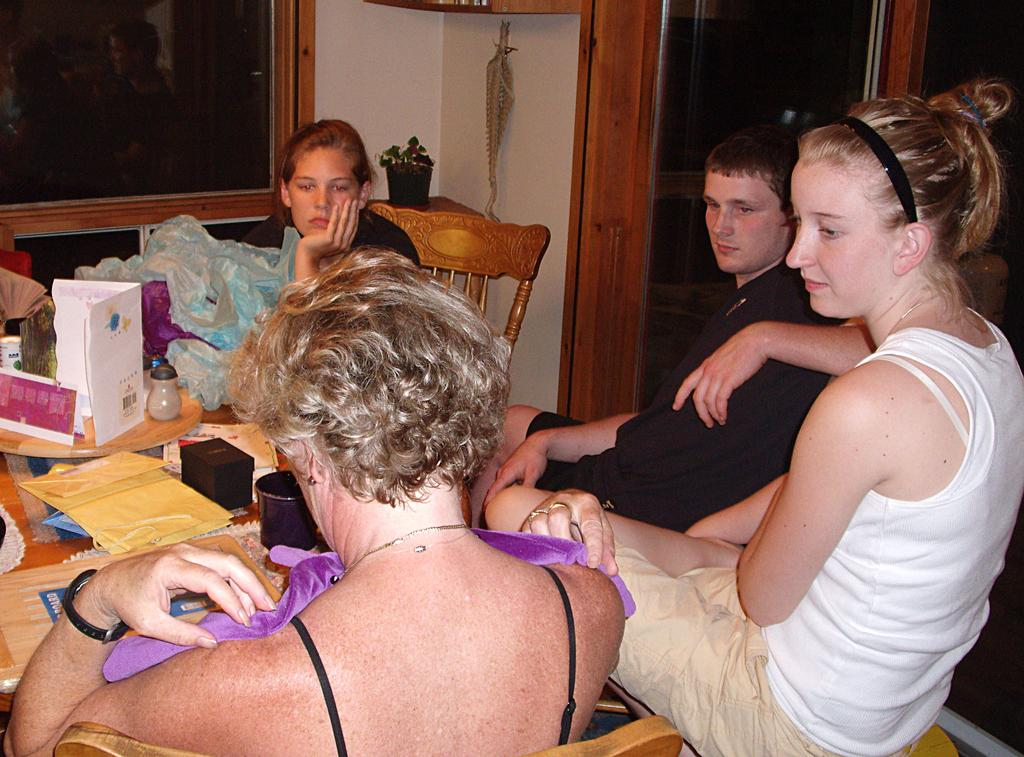How many people are in the image? There are people in the image, but the exact number is not specified. What type of plant is in the image? There is a plant in the image, but the specific type is not mentioned. What type of furniture is in the image? There are chairs in the image, and there is also a table. What activity might be taking place in the image? The presence of cards suggests that a card game might be happening. What else can be seen in the image? There are clothes and some other objects in the image. What type of destruction can be seen happening to the queen in the image? There is no queen or destruction present in the image. What type of noise can be heard coming from the objects in the image? There is no noise present in the image, as it is a still image. 